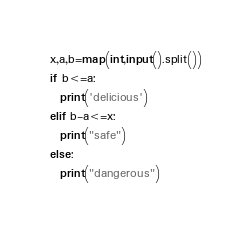<code> <loc_0><loc_0><loc_500><loc_500><_Python_>x,a,b=map(int,input().split())
if b<=a:
  print('delicious')
elif b-a<=x:
  print("safe")
else:
  print("dangerous")</code> 